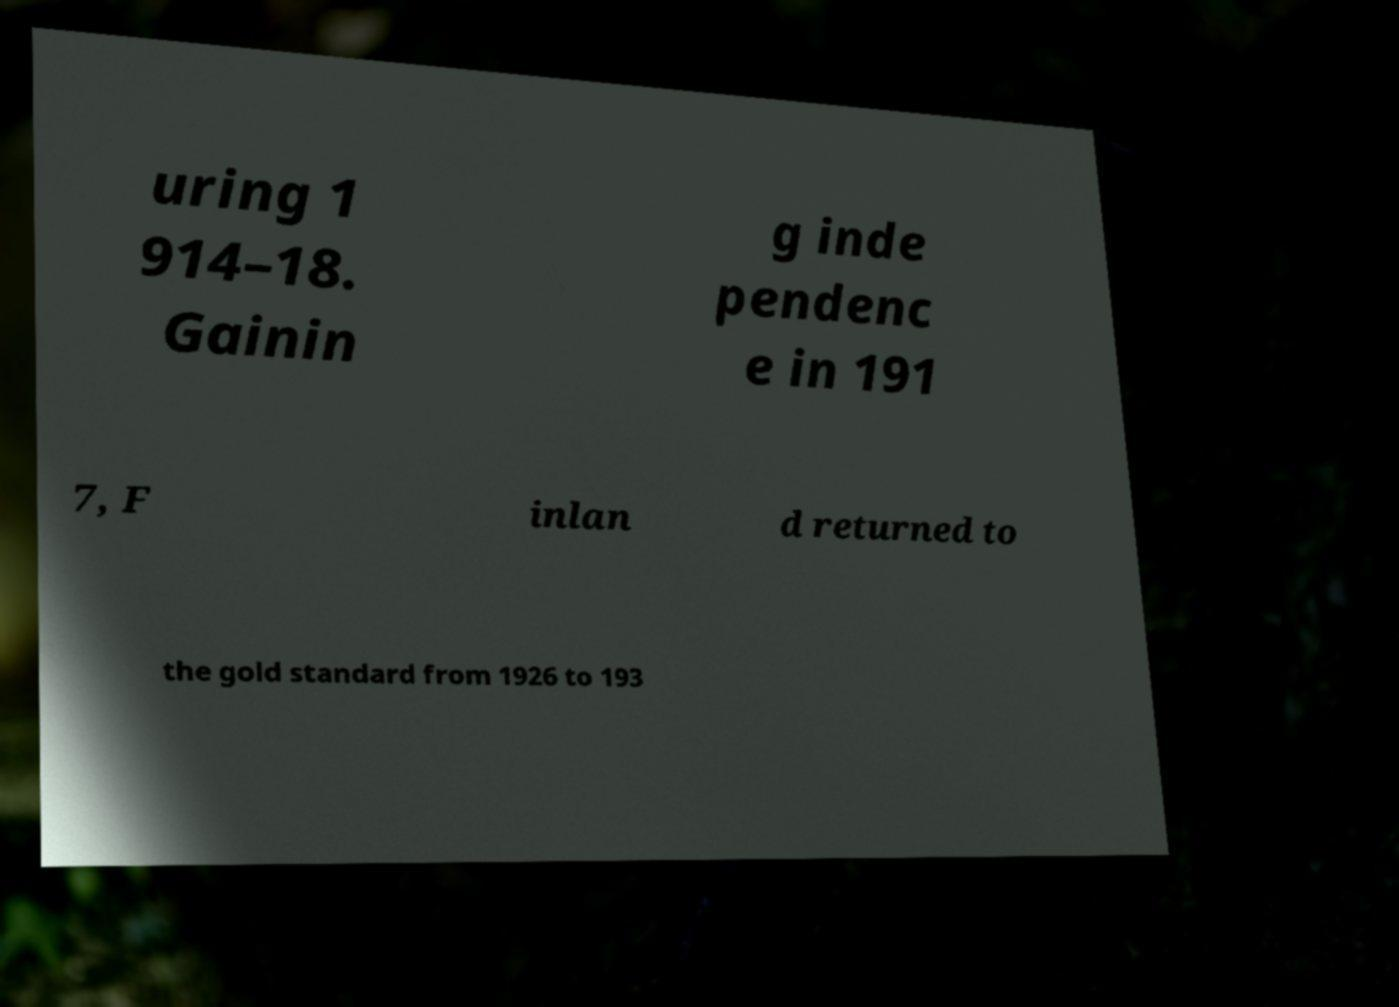What messages or text are displayed in this image? I need them in a readable, typed format. uring 1 914–18. Gainin g inde pendenc e in 191 7, F inlan d returned to the gold standard from 1926 to 193 